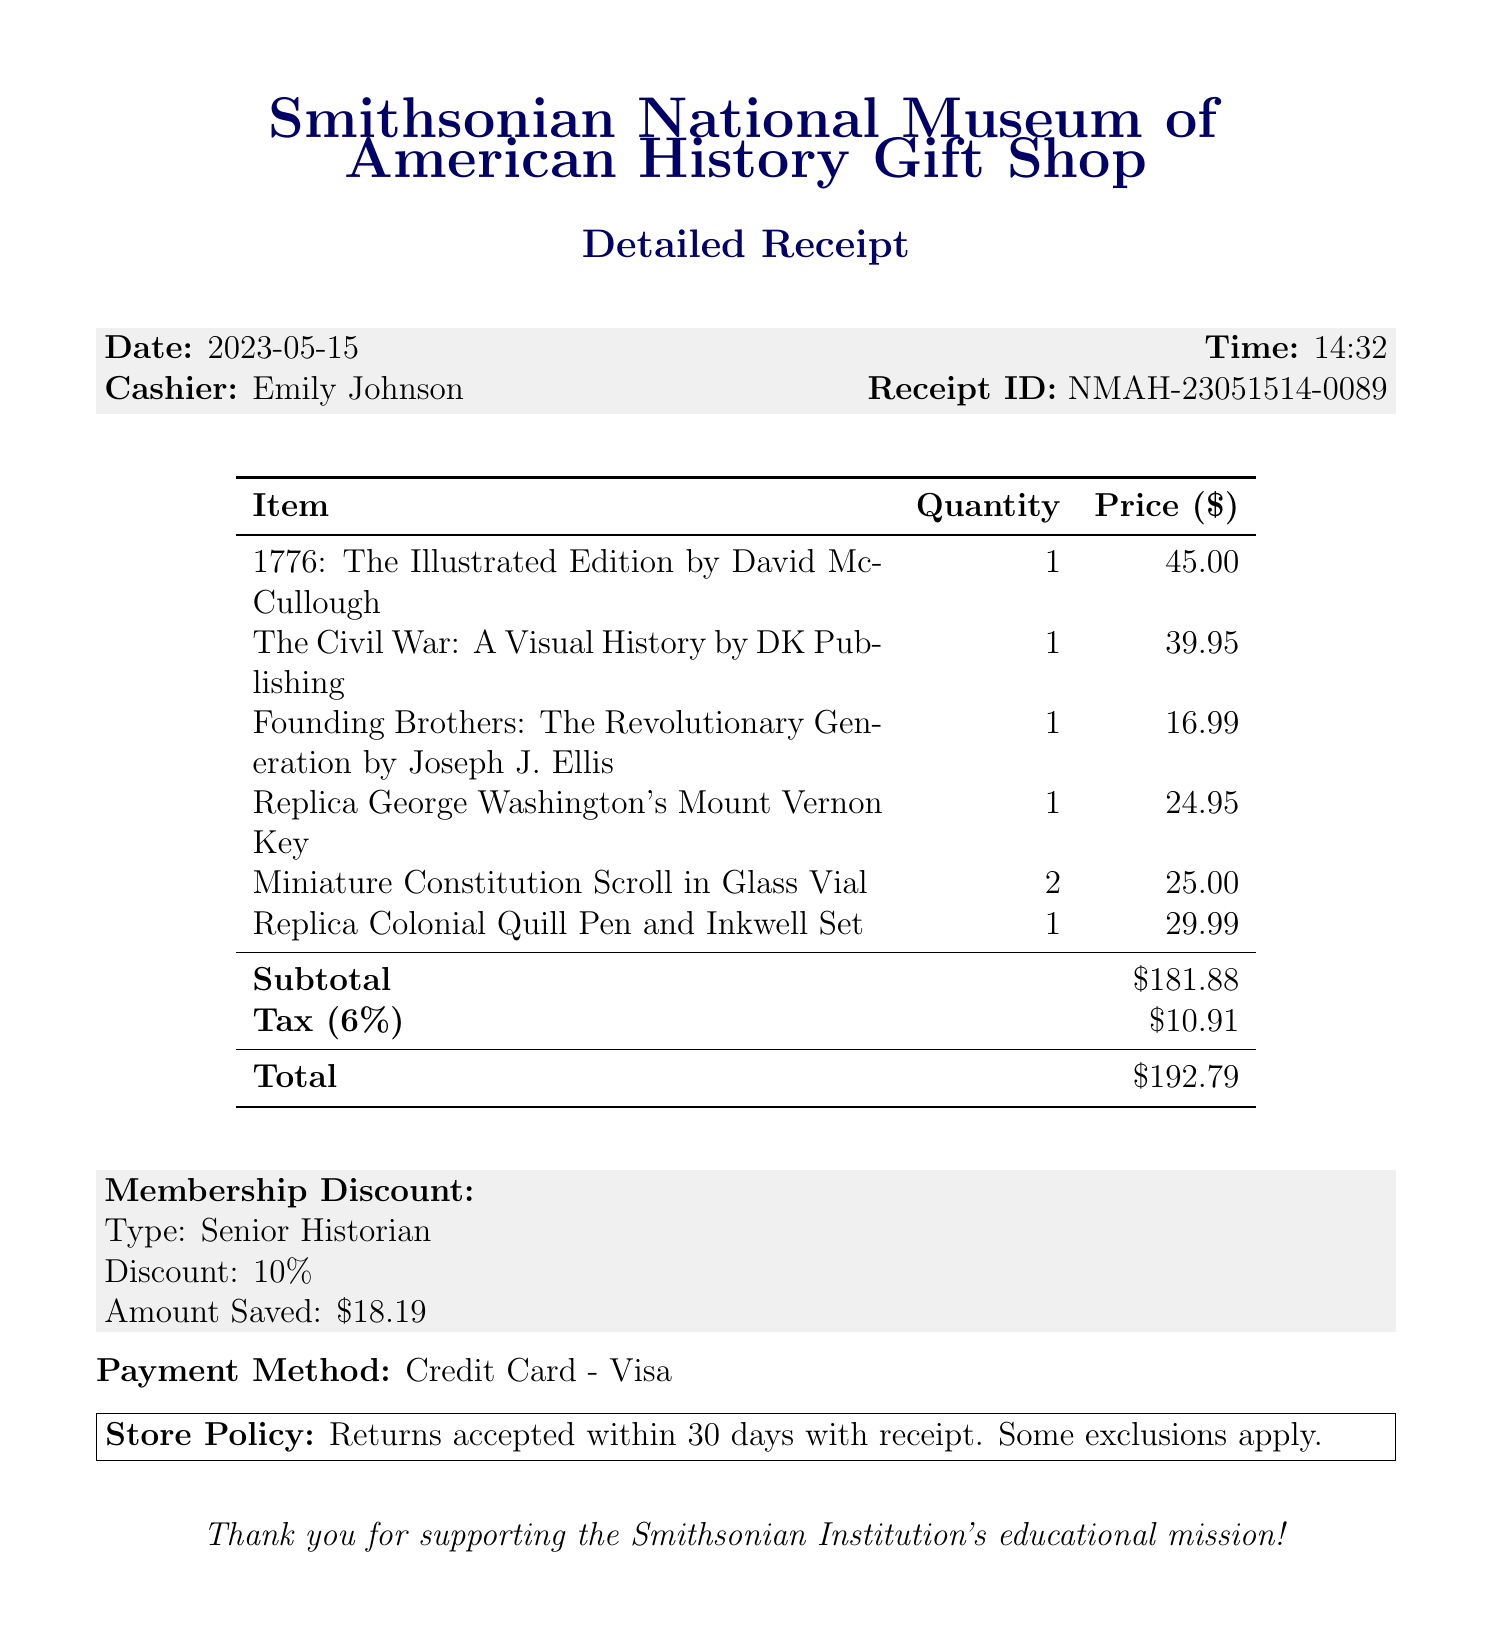What is the store name? The store name is listed as part of the receipt header.
Answer: Smithsonian National Museum of American History Gift Shop What date was the purchase made? The date of the purchase is provided in the receipt details.
Answer: 2023-05-15 Who was the cashier for this transaction? The cashier's name appears in the receipt information.
Answer: Emily Johnson What is the subtotal amount? The subtotal is a specific financial detail included in the receipt breakdown.
Answer: $181.88 What is the tax rate applied to the purchase? The tax rate is stated in the tax detail section of the receipt.
Answer: 6% How much was saved with the membership discount? The amount saved through the membership discount is specified in the receipt.
Answer: $18.19 How many items were purchased in total? This can be calculated from the quantity of each item listed in the receipt.
Answer: 6 What is the payment method used? The payment method is clearly indicated in the document.
Answer: Credit Card - Visa What is the store policy regarding returns? The store policy is stated clearly towards the end of the receipt.
Answer: Returns accepted within 30 days with receipt. Some exclusions apply 